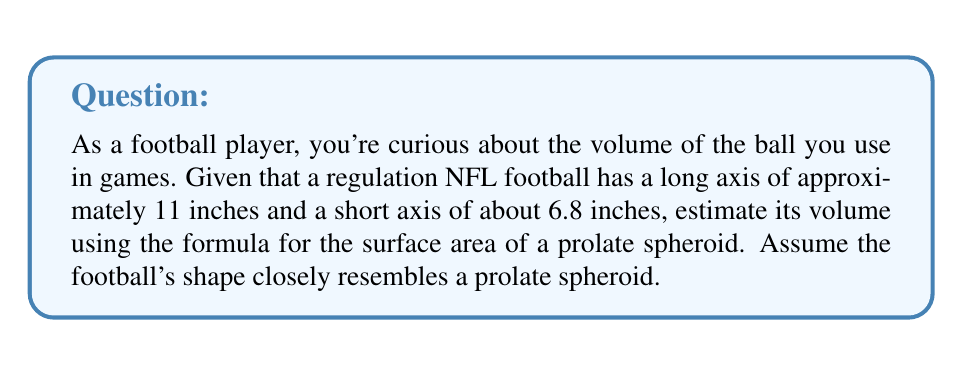Can you answer this question? Let's approach this step-by-step:

1) A prolate spheroid has a surface area given by the formula:

   $$A = 2\pi a^2 + \frac{2\pi ab}{\sin^{-1}e} \cdot e$$

   where $a$ is the semi-minor axis, $b$ is the semi-major axis, and $e$ is the eccentricity.

2) We're given the full axes, so let's halve them for our calculations:
   $a = 6.8/2 = 3.4$ inches
   $b = 11/2 = 5.5$ inches

3) Calculate the eccentricity:
   $$e = \sqrt{1 - \frac{a^2}{b^2}} = \sqrt{1 - \frac{3.4^2}{5.5^2}} \approx 0.7857$$

4) Now we can calculate the surface area:
   $$A = 2\pi(3.4)^2 + \frac{2\pi(3.4)(5.5)}{\sin^{-1}(0.7857)} \cdot 0.7857 \approx 191.82 \text{ sq inches}$$

5) To estimate the volume, we can use the relationship between surface area and volume for a sphere. For a sphere, $V = \frac{r}{3}A$, where $r$ is the radius.

6) For our prolate spheroid, let's use the average of our semi-axes as an effective radius:
   $$r_{eff} = \frac{a + b}{2} = \frac{3.4 + 5.5}{2} = 4.45 \text{ inches}$$

7) Now we can estimate the volume:
   $$V \approx \frac{r_{eff}}{3}A = \frac{4.45}{3} \cdot 191.82 \approx 284.86 \text{ cubic inches}$$
Answer: $\approx 284.86 \text{ cubic inches}$ 